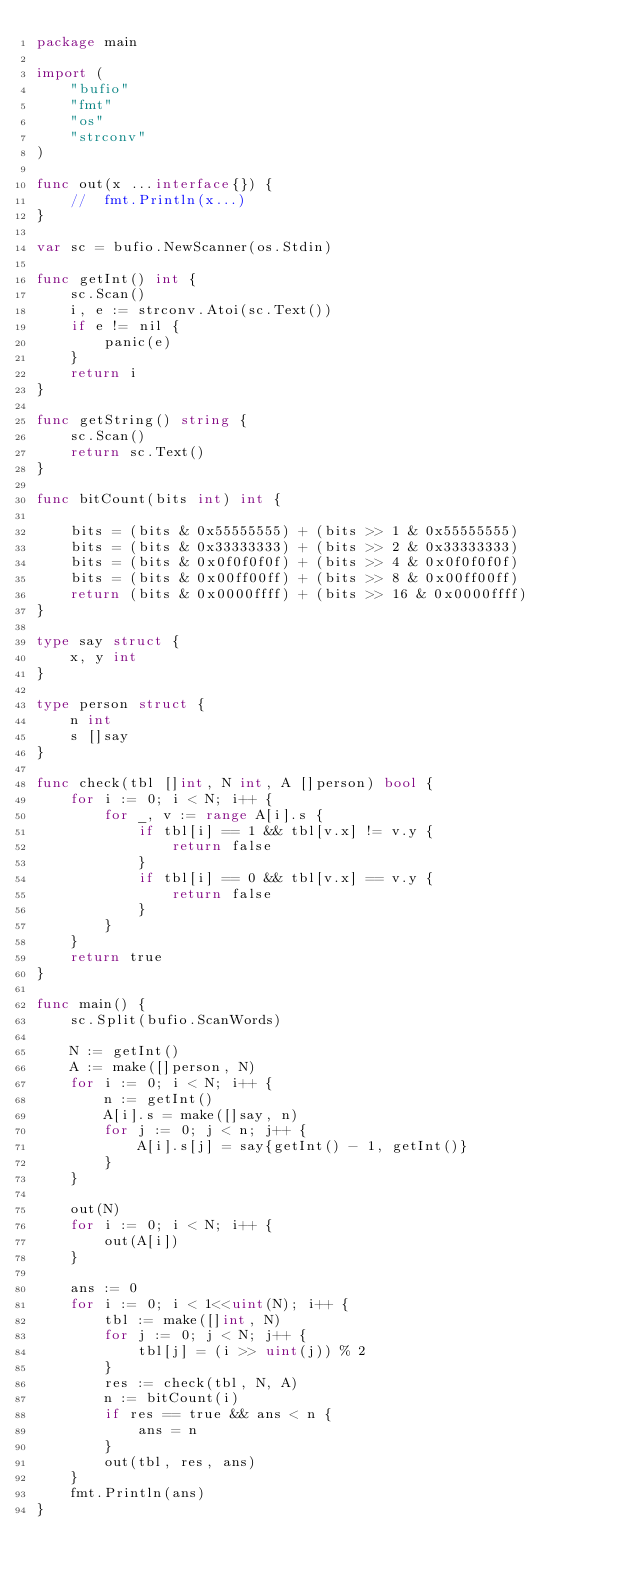Convert code to text. <code><loc_0><loc_0><loc_500><loc_500><_Go_>package main

import (
	"bufio"
	"fmt"
	"os"
	"strconv"
)

func out(x ...interface{}) {
	//	fmt.Println(x...)
}

var sc = bufio.NewScanner(os.Stdin)

func getInt() int {
	sc.Scan()
	i, e := strconv.Atoi(sc.Text())
	if e != nil {
		panic(e)
	}
	return i
}

func getString() string {
	sc.Scan()
	return sc.Text()
}

func bitCount(bits int) int {

	bits = (bits & 0x55555555) + (bits >> 1 & 0x55555555)
	bits = (bits & 0x33333333) + (bits >> 2 & 0x33333333)
	bits = (bits & 0x0f0f0f0f) + (bits >> 4 & 0x0f0f0f0f)
	bits = (bits & 0x00ff00ff) + (bits >> 8 & 0x00ff00ff)
	return (bits & 0x0000ffff) + (bits >> 16 & 0x0000ffff)
}

type say struct {
	x, y int
}

type person struct {
	n int
	s []say
}

func check(tbl []int, N int, A []person) bool {
	for i := 0; i < N; i++ {
		for _, v := range A[i].s {
			if tbl[i] == 1 && tbl[v.x] != v.y {
				return false
			}
			if tbl[i] == 0 && tbl[v.x] == v.y {
				return false
			}
		}
	}
	return true
}

func main() {
	sc.Split(bufio.ScanWords)

	N := getInt()
	A := make([]person, N)
	for i := 0; i < N; i++ {
		n := getInt()
		A[i].s = make([]say, n)
		for j := 0; j < n; j++ {
			A[i].s[j] = say{getInt() - 1, getInt()}
		}
	}

	out(N)
	for i := 0; i < N; i++ {
		out(A[i])
	}

	ans := 0
	for i := 0; i < 1<<uint(N); i++ {
		tbl := make([]int, N)
		for j := 0; j < N; j++ {
			tbl[j] = (i >> uint(j)) % 2
		}
		res := check(tbl, N, A)
		n := bitCount(i)
		if res == true && ans < n {
			ans = n
		}
		out(tbl, res, ans)
	}
	fmt.Println(ans)
}
</code> 